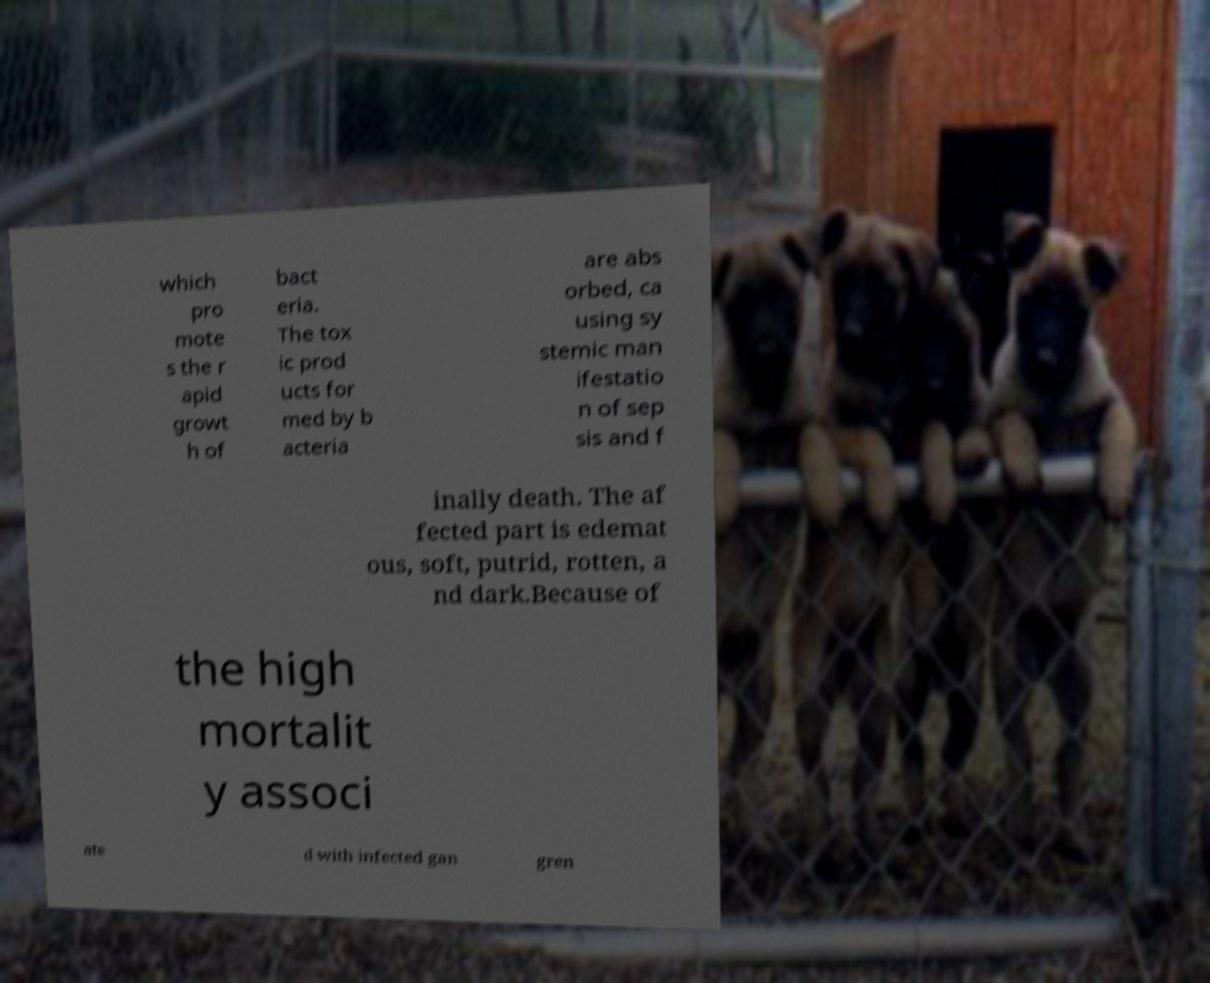For documentation purposes, I need the text within this image transcribed. Could you provide that? which pro mote s the r apid growt h of bact eria. The tox ic prod ucts for med by b acteria are abs orbed, ca using sy stemic man ifestatio n of sep sis and f inally death. The af fected part is edemat ous, soft, putrid, rotten, a nd dark.Because of the high mortalit y associ ate d with infected gan gren 